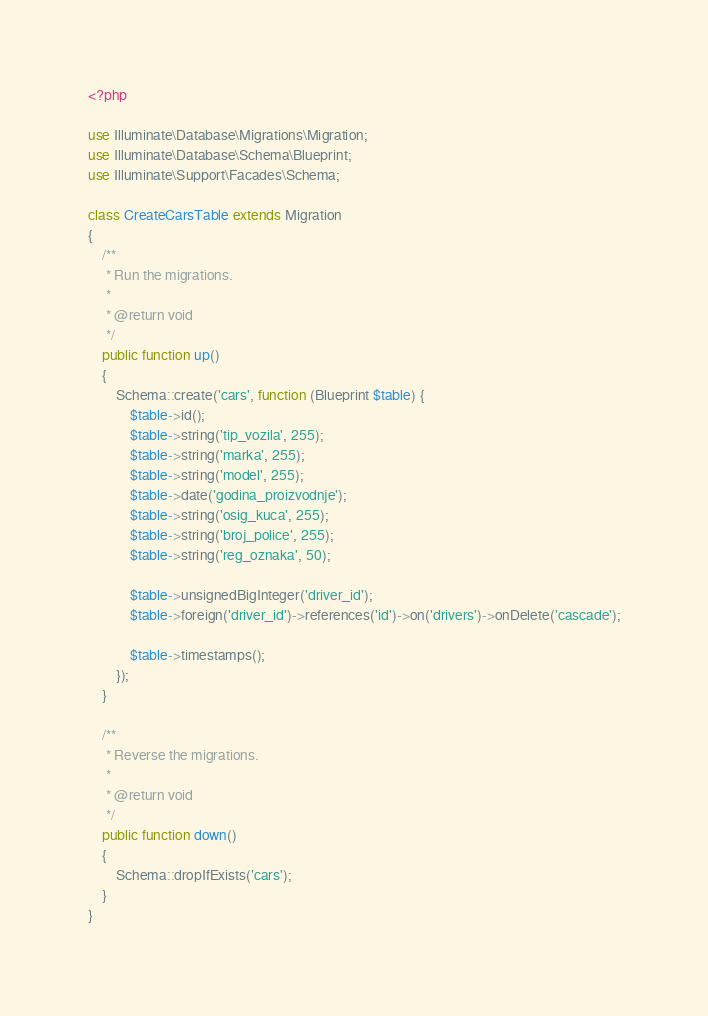Convert code to text. <code><loc_0><loc_0><loc_500><loc_500><_PHP_><?php

use Illuminate\Database\Migrations\Migration;
use Illuminate\Database\Schema\Blueprint;
use Illuminate\Support\Facades\Schema;

class CreateCarsTable extends Migration
{
    /**
     * Run the migrations.
     *
     * @return void
     */
    public function up()
    {
        Schema::create('cars', function (Blueprint $table) {
            $table->id();
            $table->string('tip_vozila', 255);
            $table->string('marka', 255);
            $table->string('model', 255);
            $table->date('godina_proizvodnje');
            $table->string('osig_kuca', 255);
            $table->string('broj_police', 255);
            $table->string('reg_oznaka', 50);
            
            $table->unsignedBigInteger('driver_id');
            $table->foreign('driver_id')->references('id')->on('drivers')->onDelete('cascade');
            
            $table->timestamps();
        });
    }

    /**
     * Reverse the migrations.
     *
     * @return void
     */
    public function down()
    {
        Schema::dropIfExists('cars');
    }
}
</code> 